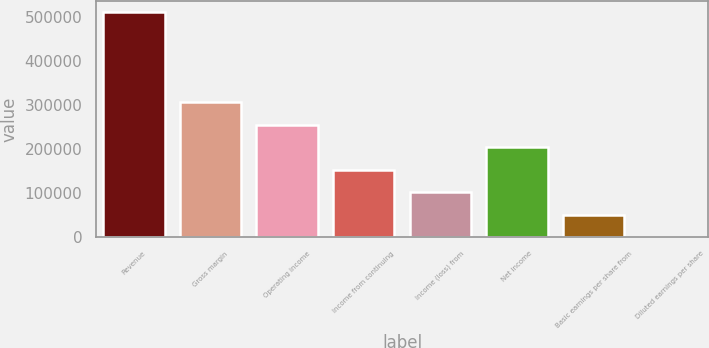Convert chart to OTSL. <chart><loc_0><loc_0><loc_500><loc_500><bar_chart><fcel>Revenue<fcel>Gross margin<fcel>Operating income<fcel>Income from continuing<fcel>Income (loss) from<fcel>Net income<fcel>Basic earnings per share from<fcel>Diluted earnings per share<nl><fcel>510870<fcel>306522<fcel>255435<fcel>153261<fcel>102174<fcel>204348<fcel>51087.2<fcel>0.22<nl></chart> 